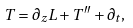<formula> <loc_0><loc_0><loc_500><loc_500>T = \partial _ { z } L + T ^ { \prime \prime } + \partial _ { t } ,</formula> 